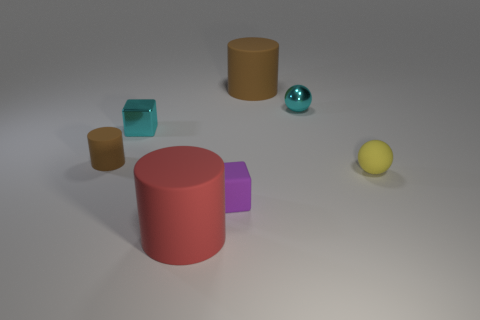Can you describe the shapes and colors of the objects in the image? Certainly! The image showcases a variety of geometric shapes in different colors. There is a large pink cylinder, a medium-sized brown cylinder, a smaller yellow sphere, a teal cube, and a cyan, shiny ball that appears metallic. The arrangement is set against a neutral gray background. 